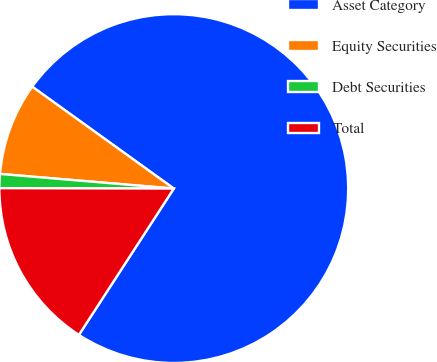<chart> <loc_0><loc_0><loc_500><loc_500><pie_chart><fcel>Asset Category<fcel>Equity Securities<fcel>Debt Securities<fcel>Total<nl><fcel>74.23%<fcel>8.59%<fcel>1.3%<fcel>15.88%<nl></chart> 